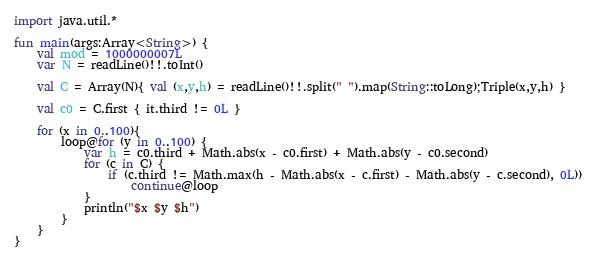<code> <loc_0><loc_0><loc_500><loc_500><_Kotlin_>import java.util.*

fun main(args:Array<String>) {
    val mod = 1000000007L
    var N = readLine()!!.toInt()

    val C = Array(N){ val (x,y,h) = readLine()!!.split(" ").map(String::toLong);Triple(x,y,h) }

    val c0 = C.first { it.third != 0L }

    for (x in 0..100){
        loop@for (y in 0..100) {
            var h = c0.third + Math.abs(x - c0.first) + Math.abs(y - c0.second)
            for (c in C) {
                if (c.third != Math.max(h - Math.abs(x - c.first) - Math.abs(y - c.second), 0L))
                    continue@loop
            }
            println("$x $y $h")
        }
    }
}</code> 